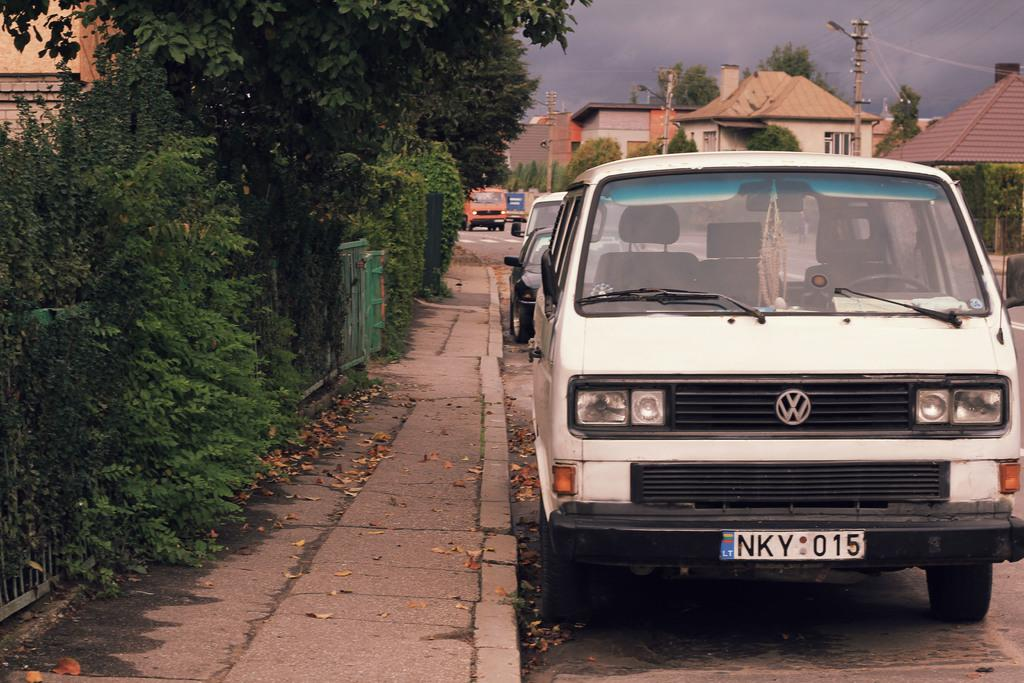What types of objects can be seen in the image? There are vehicles, buildings, poles, and street lights in the image. What else can be seen in the image? The sky and trees are visible in the image. Is there any text or writing present in the image? Yes, there is text or writing present in the image. Can you tell me how many snakes are slithering on the street lights in the image? There are no snakes present in the image; it features vehicles, buildings, poles, street lights, the sky, trees, and text or writing. What type of joke is being told by the street lights in the image? There is no joke being told by the street lights in the image; they are simply illuminating the scene. 